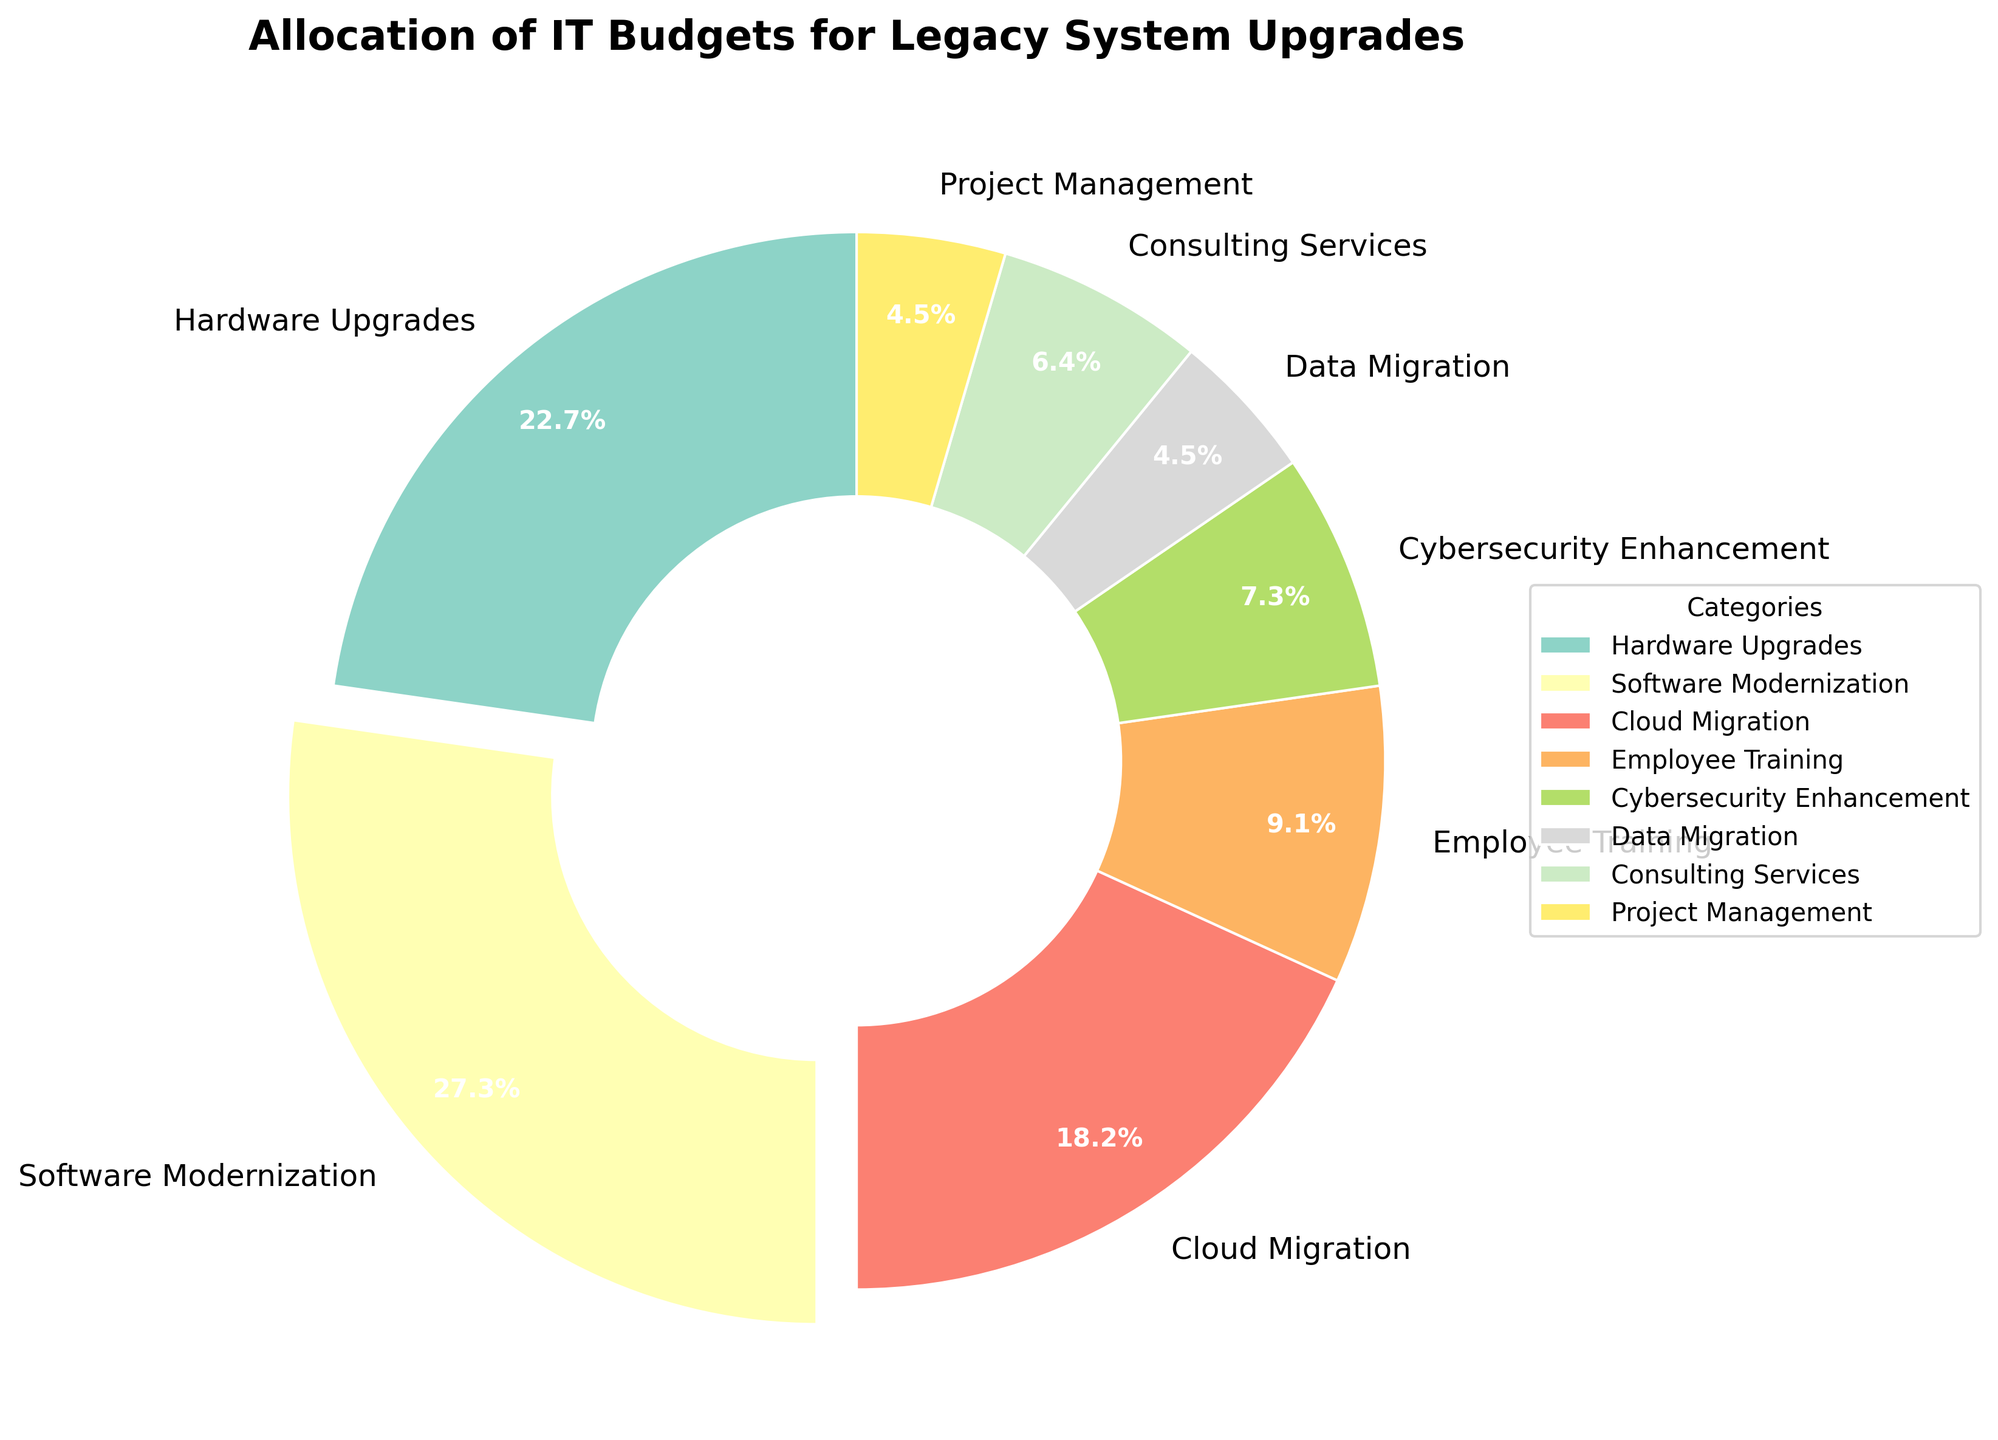What is the largest allocation category for the IT budget? The largest allocation is shown by the largest slice of the pie chart, which is the 'Software Modernization' category.
Answer: Software Modernization What is the combined percentage of the 'Cloud Migration' and 'Employee Training' categories? The 'Cloud Migration' slice has a 20% allocation, and the 'Employee Training' slice has a 10% allocation. Adding these two percentages together gives us 20% + 10% = 30%.
Answer: 30% Which category has a smaller allocation: 'Cybersecurity Enhancement' or 'Consulting Services'? By comparing the slices, the 'Cybersecurity Enhancement' category has an 8% allocation, while the 'Consulting Services' category has a 7% allocation. Hence, 'Consulting Services' has a smaller allocation.
Answer: Consulting Services How much more is allocated to 'Hardware Upgrades' compared to 'Data Migration'? 'Hardware Upgrades' has a 25% allocation, and 'Data Migration' has a 5% allocation. The difference between them is 25% - 5% = 20%.
Answer: 20% Identify the category with the smallest allocation and state its percentage. The smallest slice corresponds to the 'Data Migration' and 'Project Management' categories, each with a 5% allocation.
Answer: Data Migration and Project Management, 5% What is the total percentage allocated to categories that have less than a 10% share? The relevant categories are 'Cybersecurity Enhancement' (8%), 'Data Migration' (5%), 'Consulting Services' (7%), and 'Project Management' (5%). Summing these percentages gives 8% + 5% + 7% + 5% = 25%.
Answer: 25% Which category stands out visually in the pie chart and why? The 'Software Modernization' category stands out because it is slightly exploded (separated from the rest of the pie chart), indicating its significance as the largest allocation.
Answer: Software Modernization Are the combined allocations for 'Cybersecurity Enhancement' and 'Consulting Services' greater than the allocation for 'Employee Training'? Adding 'Cybersecurity Enhancement' (8%) and 'Consulting Services' (7%) gives 8% + 7% = 15%, which is greater than the 10% allocated to 'Employee Training'.
Answer: Yes What are the categories with an allocation equal to or less than 7%? These categories are identified by examining the slices in the pie chart: 'Consulting Services' at 7% and 'Data Migration' and 'Project Management', both at 5%.
Answer: Consulting Services, Data Migration, and Project Management If the 'Hardware Upgrades' allocation increased by 5%, what would be its new percentage? Currently, 'Hardware Upgrades' is at 25%. Adding the 5% increase: 25% + 5% = 30%.
Answer: 30% 